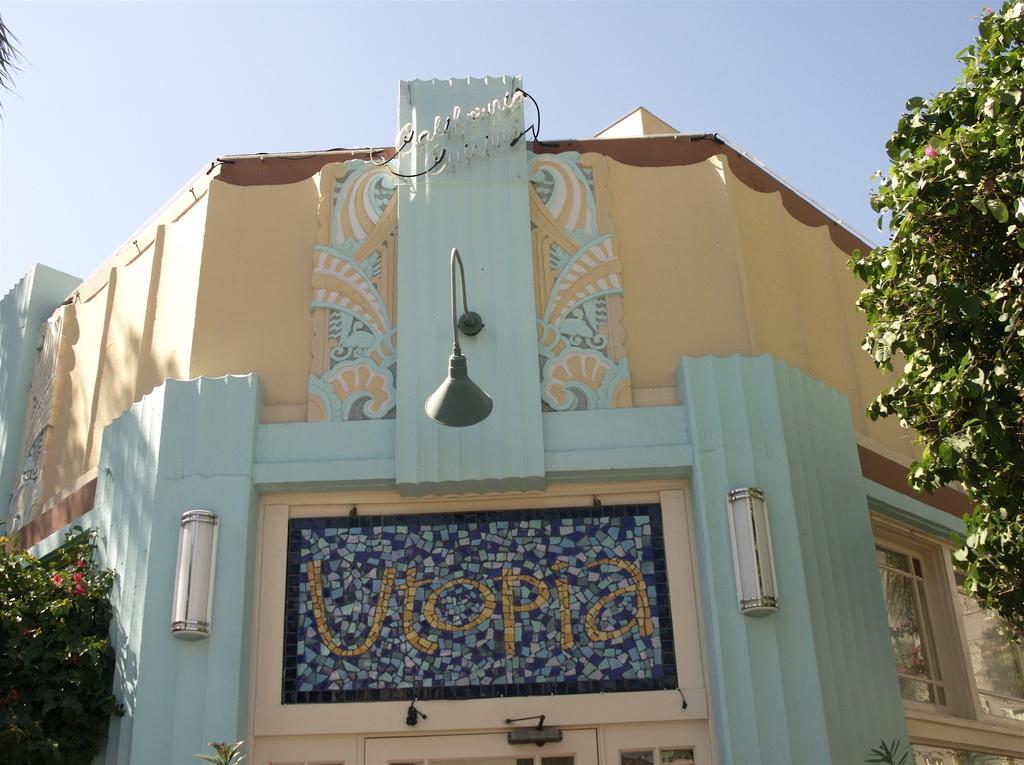Please provide a concise description of this image. In this picture I can see the trees on either side of this image, in the middle there is a board on this building. At the top there is the sky. 